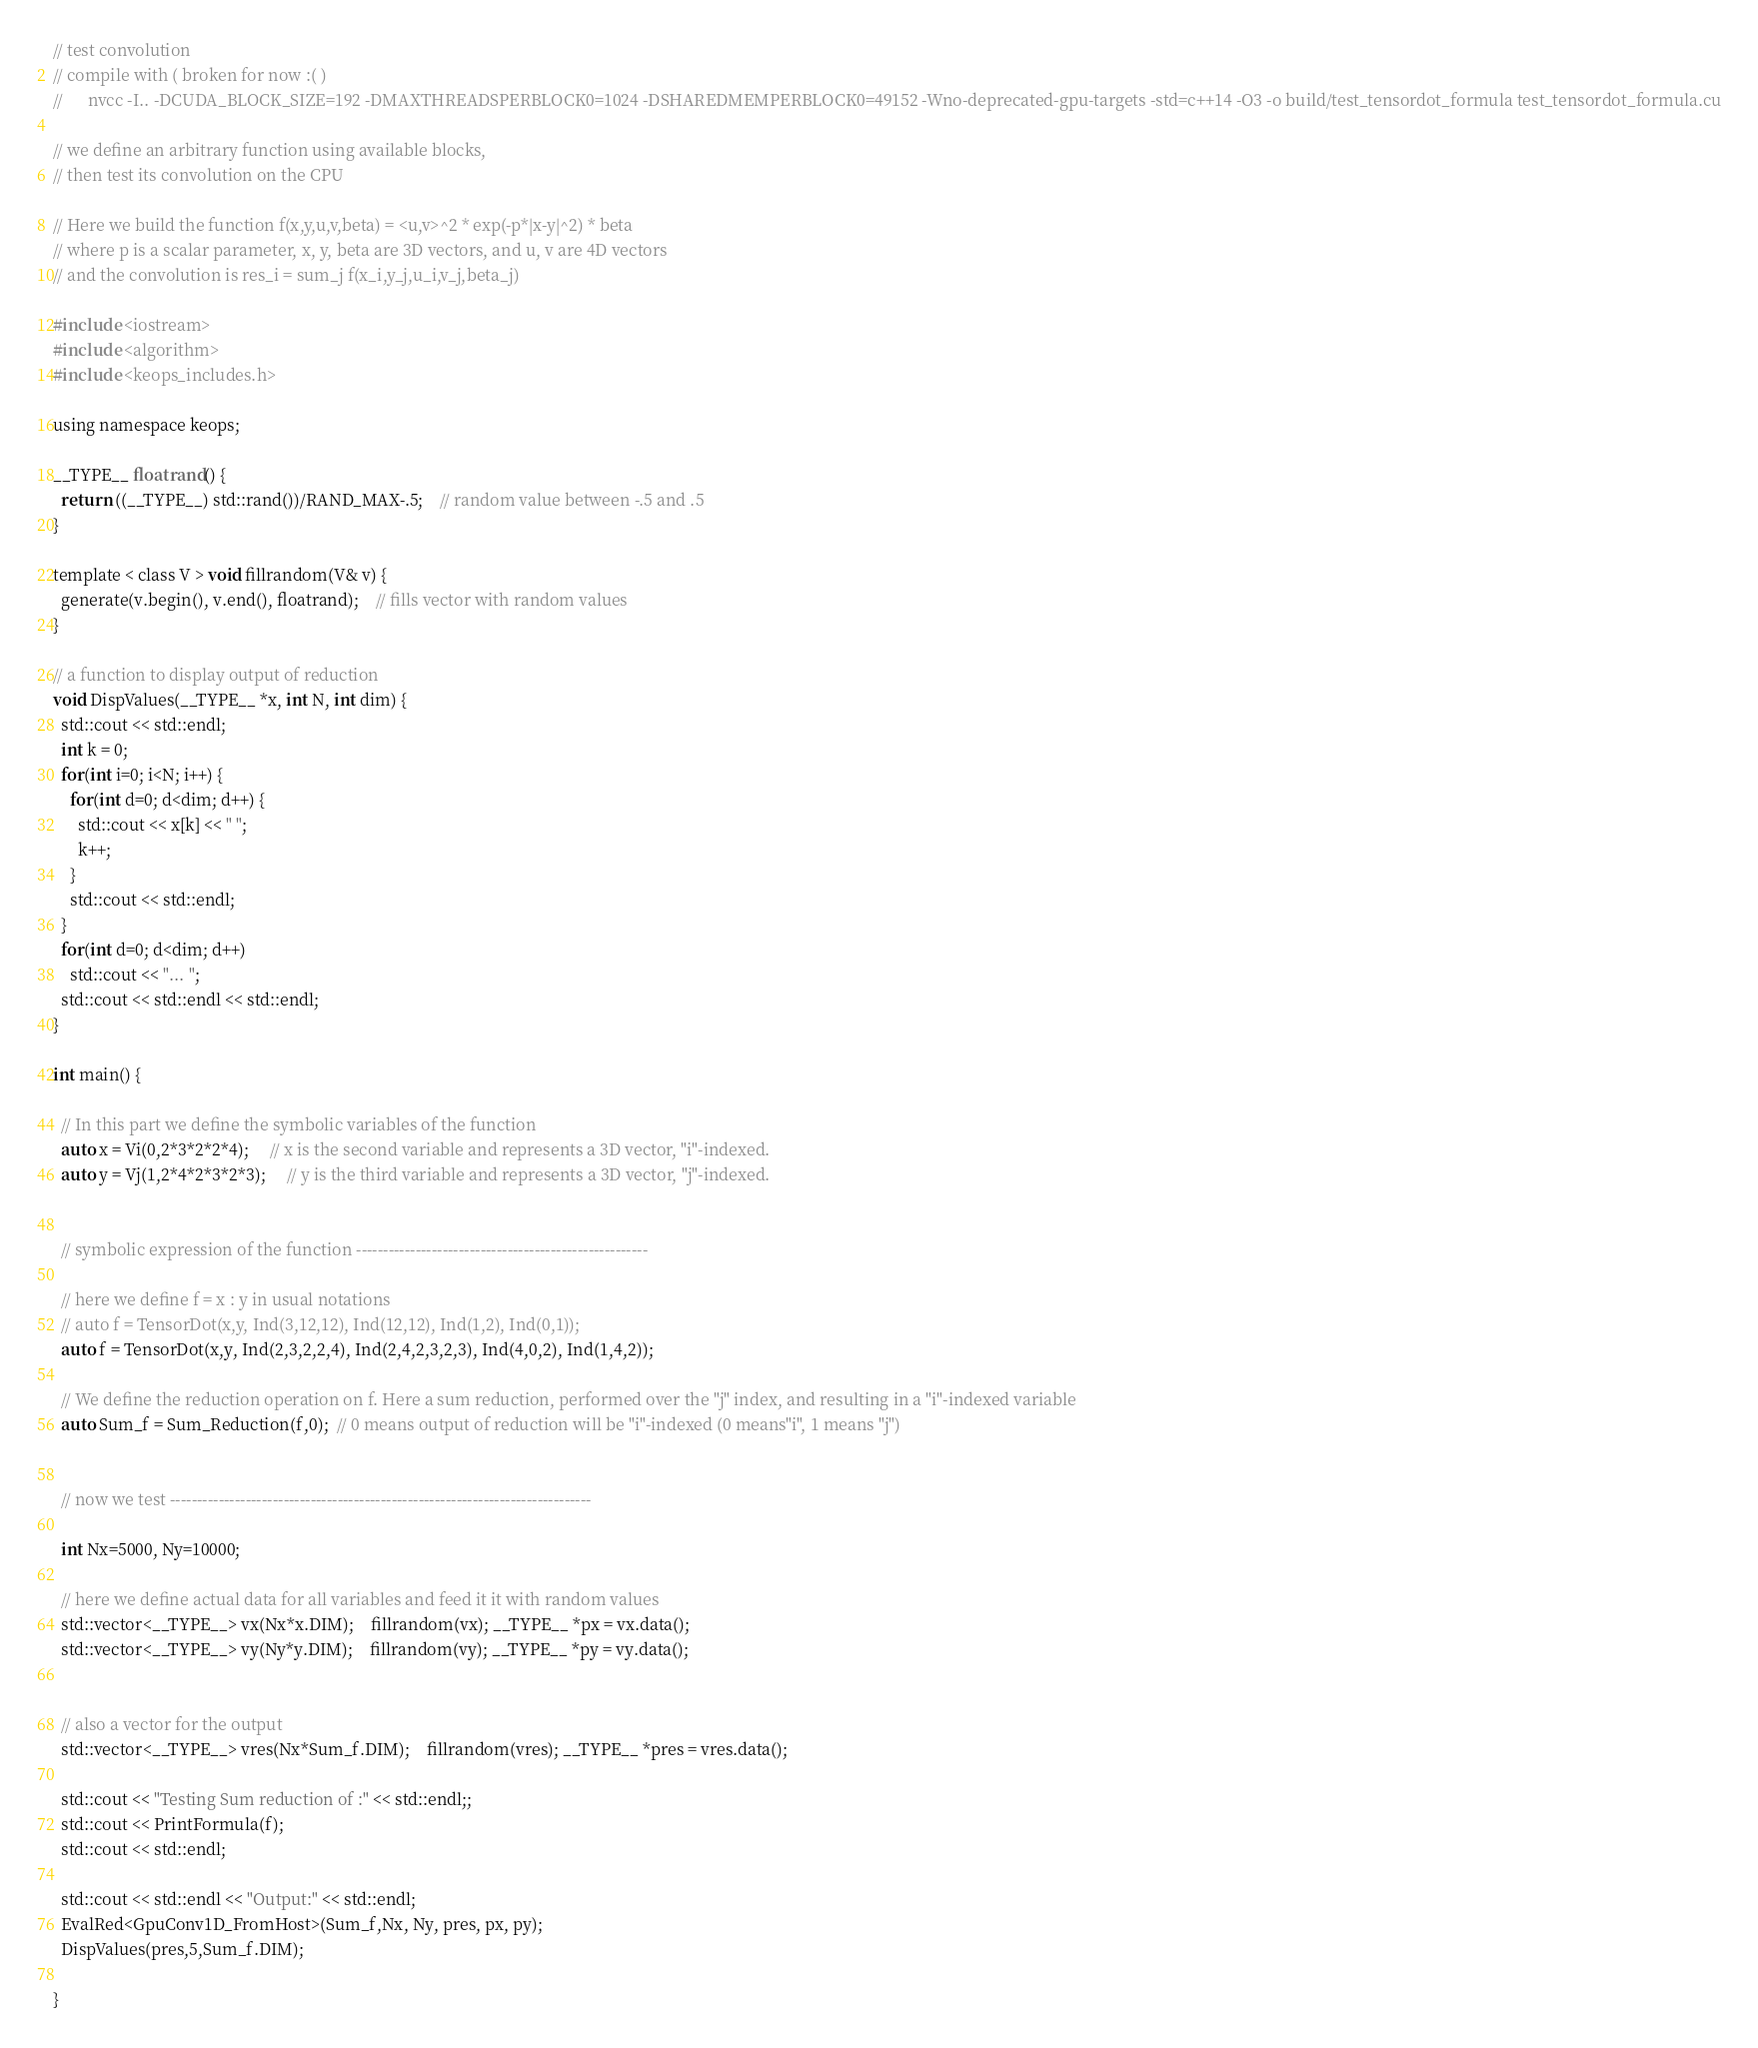Convert code to text. <code><loc_0><loc_0><loc_500><loc_500><_Cuda_>// test convolution
// compile with ( broken for now :( )
//		nvcc -I.. -DCUDA_BLOCK_SIZE=192 -DMAXTHREADSPERBLOCK0=1024 -DSHAREDMEMPERBLOCK0=49152 -Wno-deprecated-gpu-targets -std=c++14 -O3 -o build/test_tensordot_formula test_tensordot_formula.cu

// we define an arbitrary function using available blocks,
// then test its convolution on the CPU

// Here we build the function f(x,y,u,v,beta) = <u,v>^2 * exp(-p*|x-y|^2) * beta
// where p is a scalar parameter, x, y, beta are 3D vectors, and u, v are 4D vectors
// and the convolution is res_i = sum_j f(x_i,y_j,u_i,v_j,beta_j)

#include <iostream>
#include <algorithm>
#include <keops_includes.h>

using namespace keops;

__TYPE__ floatrand() {
  return ((__TYPE__) std::rand())/RAND_MAX-.5;    // random value between -.5 and .5
}

template < class V > void fillrandom(V& v) {
  generate(v.begin(), v.end(), floatrand);    // fills vector with random values
}

// a function to display output of reduction
void DispValues(__TYPE__ *x, int N, int dim) {
  std::cout << std::endl;
  int k = 0;
  for(int i=0; i<N; i++) {
    for(int d=0; d<dim; d++) {
      std::cout << x[k] << " ";
      k++;
    }
    std::cout << std::endl;
  }
  for(int d=0; d<dim; d++)
    std::cout << "... ";
  std::cout << std::endl << std::endl;
}

int main() {

  // In this part we define the symbolic variables of the function
  auto x = Vi(0,2*3*2*2*4); 	 // x is the second variable and represents a 3D vector, "i"-indexed.
  auto y = Vj(1,2*4*2*3*2*3); 	 // y is the third variable and represents a 3D vector, "j"-indexed.


  // symbolic expression of the function ------------------------------------------------------

  // here we define f = x : y in usual notations
  // auto f = TensorDot(x,y, Ind(3,12,12), Ind(12,12), Ind(1,2), Ind(0,1));
  auto f = TensorDot(x,y, Ind(2,3,2,2,4), Ind(2,4,2,3,2,3), Ind(4,0,2), Ind(1,4,2));

  // We define the reduction operation on f. Here a sum reduction, performed over the "j" index, and resulting in a "i"-indexed variable
  auto Sum_f = Sum_Reduction(f,0);  // 0 means output of reduction will be "i"-indexed (0 means"i", 1 means "j")


  // now we test ------------------------------------------------------------------------------

  int Nx=5000, Ny=10000;

  // here we define actual data for all variables and feed it it with random values
  std::vector<__TYPE__> vx(Nx*x.DIM);    fillrandom(vx); __TYPE__ *px = vx.data();
  std::vector<__TYPE__> vy(Ny*y.DIM);    fillrandom(vy); __TYPE__ *py = vy.data();


  // also a vector for the output
  std::vector<__TYPE__> vres(Nx*Sum_f.DIM);    fillrandom(vres); __TYPE__ *pres = vres.data();

  std::cout << "Testing Sum reduction of :" << std::endl;;
  std::cout << PrintFormula(f);
  std::cout << std::endl;

  std::cout << std::endl << "Output:" << std::endl;
  EvalRed<GpuConv1D_FromHost>(Sum_f,Nx, Ny, pres, px, py);
  DispValues(pres,5,Sum_f.DIM);

}




</code> 